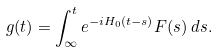<formula> <loc_0><loc_0><loc_500><loc_500>g ( t ) = \int _ { \infty } ^ { t } e ^ { - i H _ { 0 } ( t - s ) } F ( s ) \, d s .</formula> 